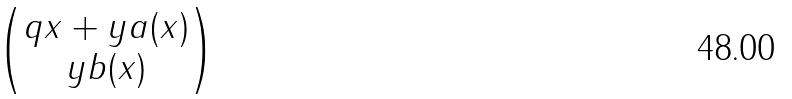Convert formula to latex. <formula><loc_0><loc_0><loc_500><loc_500>\begin{pmatrix} q x + y a ( x ) \\ y b ( x ) \end{pmatrix}</formula> 